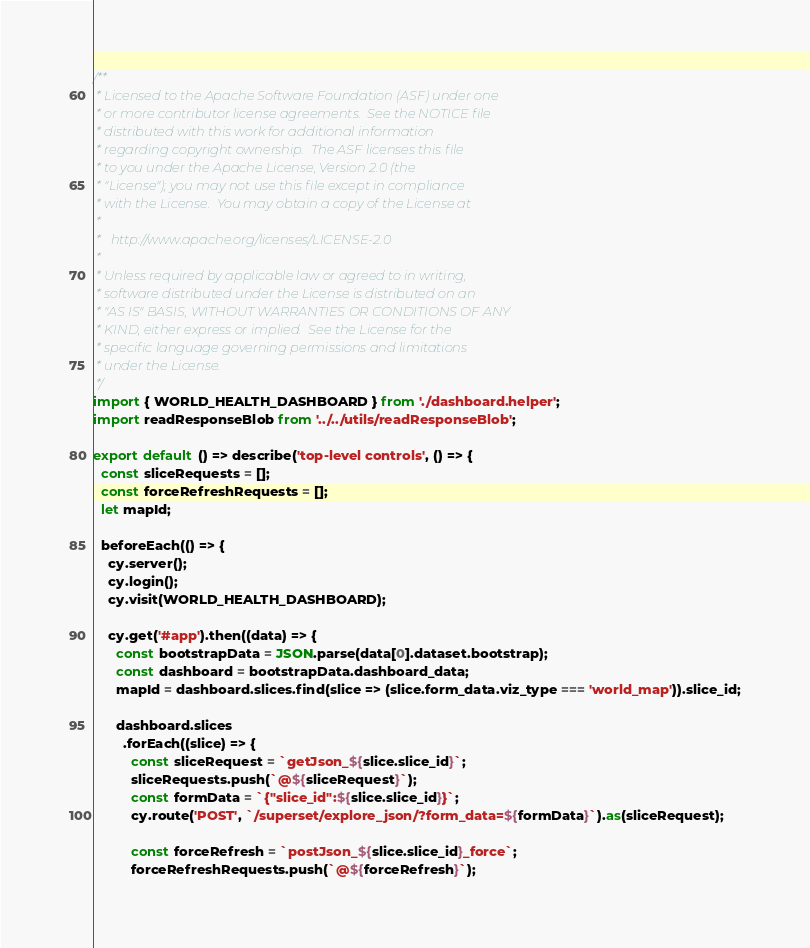<code> <loc_0><loc_0><loc_500><loc_500><_JavaScript_>/**
 * Licensed to the Apache Software Foundation (ASF) under one
 * or more contributor license agreements.  See the NOTICE file
 * distributed with this work for additional information
 * regarding copyright ownership.  The ASF licenses this file
 * to you under the Apache License, Version 2.0 (the
 * "License"); you may not use this file except in compliance
 * with the License.  You may obtain a copy of the License at
 *
 *   http://www.apache.org/licenses/LICENSE-2.0
 *
 * Unless required by applicable law or agreed to in writing,
 * software distributed under the License is distributed on an
 * "AS IS" BASIS, WITHOUT WARRANTIES OR CONDITIONS OF ANY
 * KIND, either express or implied.  See the License for the
 * specific language governing permissions and limitations
 * under the License.
 */
import { WORLD_HEALTH_DASHBOARD } from './dashboard.helper';
import readResponseBlob from '../../utils/readResponseBlob';

export default () => describe('top-level controls', () => {
  const sliceRequests = [];
  const forceRefreshRequests = [];
  let mapId;

  beforeEach(() => {
    cy.server();
    cy.login();
    cy.visit(WORLD_HEALTH_DASHBOARD);

    cy.get('#app').then((data) => {
      const bootstrapData = JSON.parse(data[0].dataset.bootstrap);
      const dashboard = bootstrapData.dashboard_data;
      mapId = dashboard.slices.find(slice => (slice.form_data.viz_type === 'world_map')).slice_id;

      dashboard.slices
        .forEach((slice) => {
          const sliceRequest = `getJson_${slice.slice_id}`;
          sliceRequests.push(`@${sliceRequest}`);
          const formData = `{"slice_id":${slice.slice_id}}`;
          cy.route('POST', `/superset/explore_json/?form_data=${formData}`).as(sliceRequest);

          const forceRefresh = `postJson_${slice.slice_id}_force`;
          forceRefreshRequests.push(`@${forceRefresh}`);</code> 